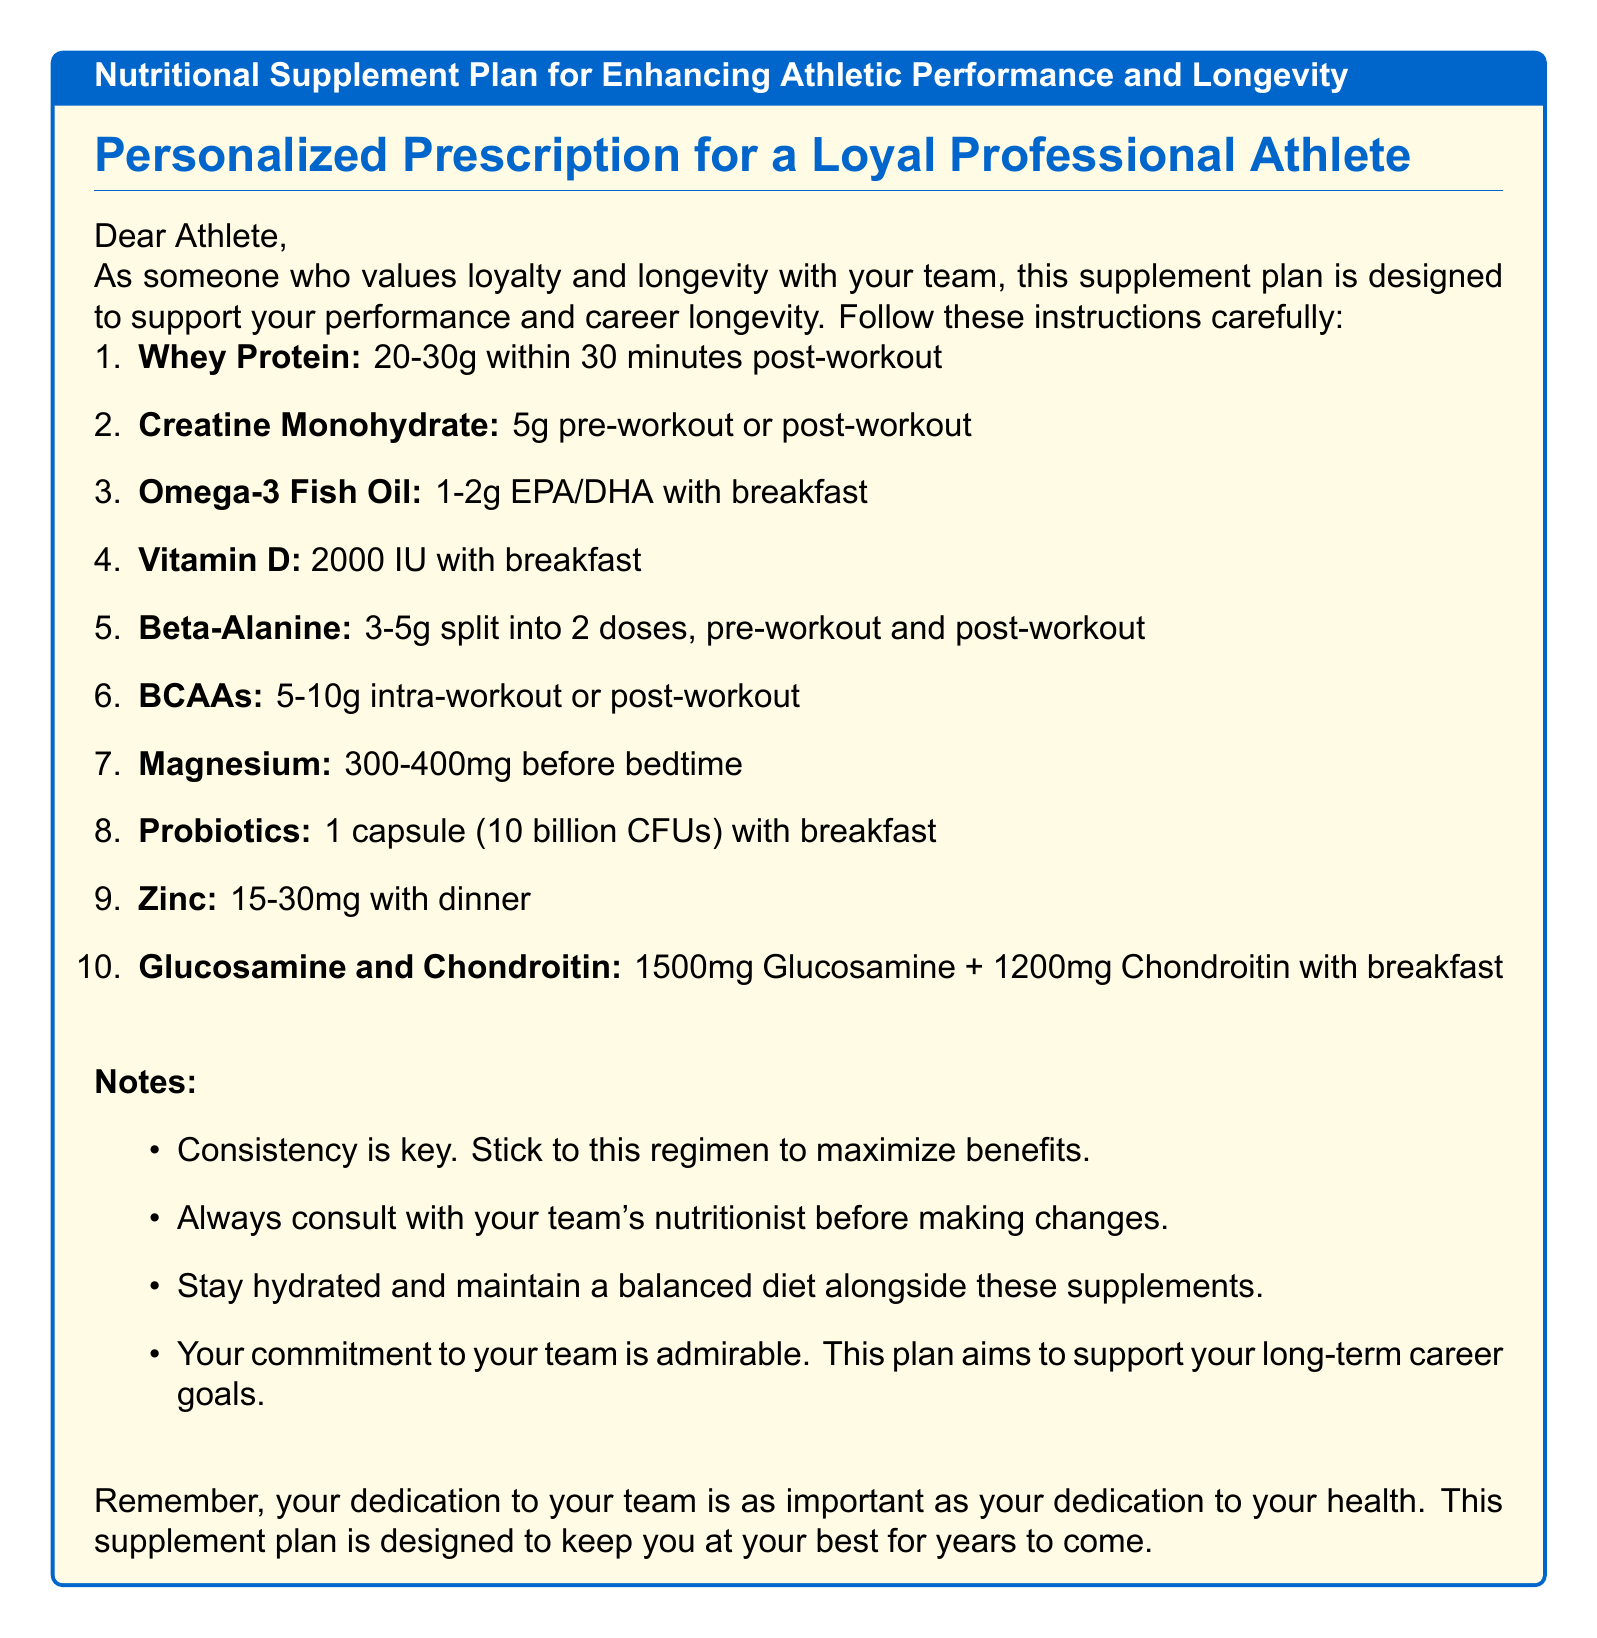What is the recommended dosage of Whey Protein? The document specifies a dosage of 20-30g within 30 minutes post-workout for Whey Protein.
Answer: 20-30g When should Omega-3 Fish Oil be taken? Omega-3 Fish Oil is recommended to be taken with breakfast according to the document.
Answer: With breakfast How much Vitamin D is prescribed? The plan prescribes 2000 IU of Vitamin D to be taken with breakfast.
Answer: 2000 IU What is the total dosage of Glucosamine and Chondroitin combined? The total dosage combines 1500mg of Glucosamine and 1200mg of Chondroitin as stated in the document.
Answer: 2700mg Which supplement is suggested to take before bedtime? The document mentions taking Magnesium before bedtime.
Answer: Magnesium What is emphasized as essential in the notes? Consistency is highlighted as essential in achieving the maximum benefits from the supplement plan.
Answer: Consistency How many doses of Beta-Alanine are recommended? The plan indicates that Beta-Alanine should be split into 2 doses.
Answer: 2 doses What is the purpose of this nutritional supplement plan? The purpose of the plan is to enhance athletic performance and support career longevity.
Answer: Enhance athletic performance and support career longevity What should be consulted before making changes to the regimen? The document advises to consult with the team's nutritionist before making any changes to the supplement regimen.
Answer: Team's nutritionist 